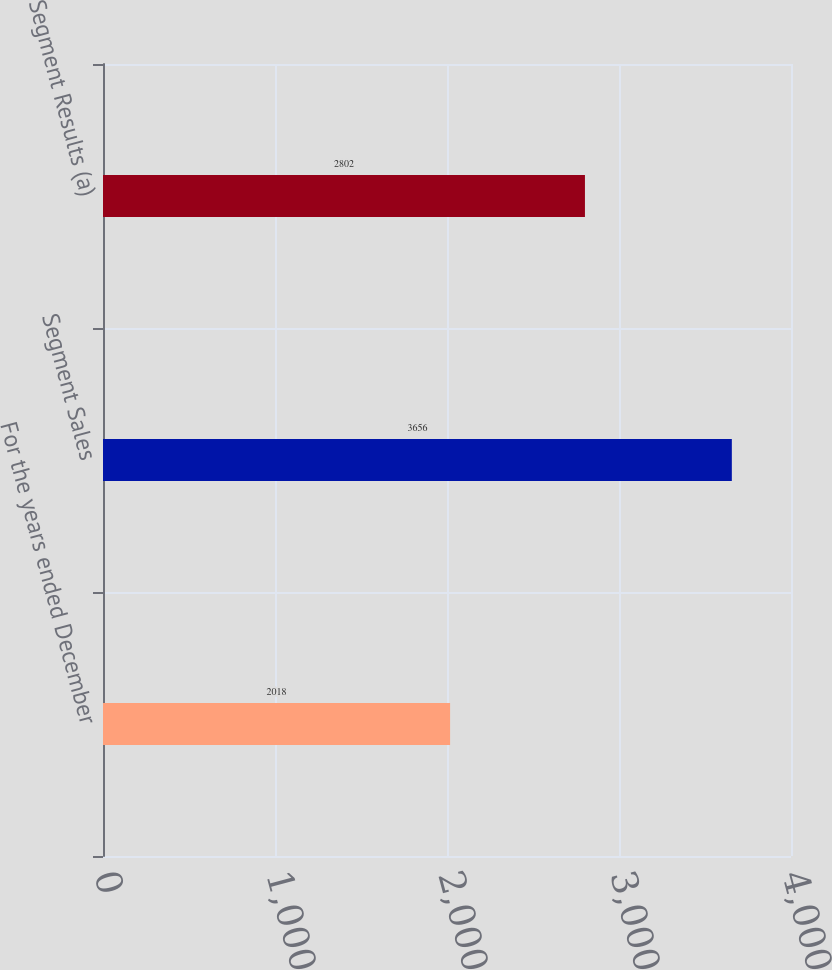Convert chart. <chart><loc_0><loc_0><loc_500><loc_500><bar_chart><fcel>For the years ended December<fcel>Segment Sales<fcel>Segment Results (a)<nl><fcel>2018<fcel>3656<fcel>2802<nl></chart> 